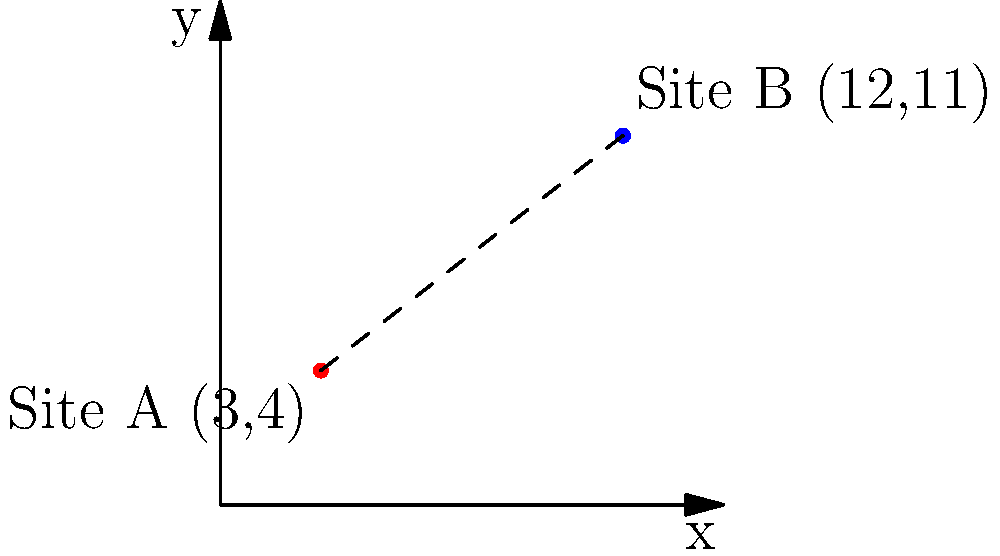As an Egyptologist working on a dig in the Nile Delta, you've discovered two important archaeological sites. Site A is located at coordinates (3,4) and Site B at (12,11) on your excavation grid, where each unit represents 100 meters. Using the distance formula, calculate the straight-line distance between these two sites in kilometers. Round your answer to two decimal places. To solve this problem, we'll use the distance formula and follow these steps:

1) The distance formula is:
   $$d = \sqrt{(x_2 - x_1)^2 + (y_2 - y_1)^2}$$

2) We have:
   Site A: $(x_1, y_1) = (3, 4)$
   Site B: $(x_2, y_2) = (12, 11)$

3) Let's substitute these values into the formula:
   $$d = \sqrt{(12 - 3)^2 + (11 - 4)^2}$$

4) Simplify inside the parentheses:
   $$d = \sqrt{9^2 + 7^2}$$

5) Calculate the squares:
   $$d = \sqrt{81 + 49}$$

6) Add inside the square root:
   $$d = \sqrt{130}$$

7) Calculate the square root:
   $$d \approx 11.40175...$$

8) Remember, each unit represents 100 meters. So multiply by 100:
   $$11.40175... * 100 = 1140.175...$$meters

9) Convert to kilometers:
   $$1140.175... / 1000 \approx 1.14$$km (rounded to two decimal places)

Therefore, the distance between the two sites is approximately 1.14 kilometers.
Answer: 1.14 km 